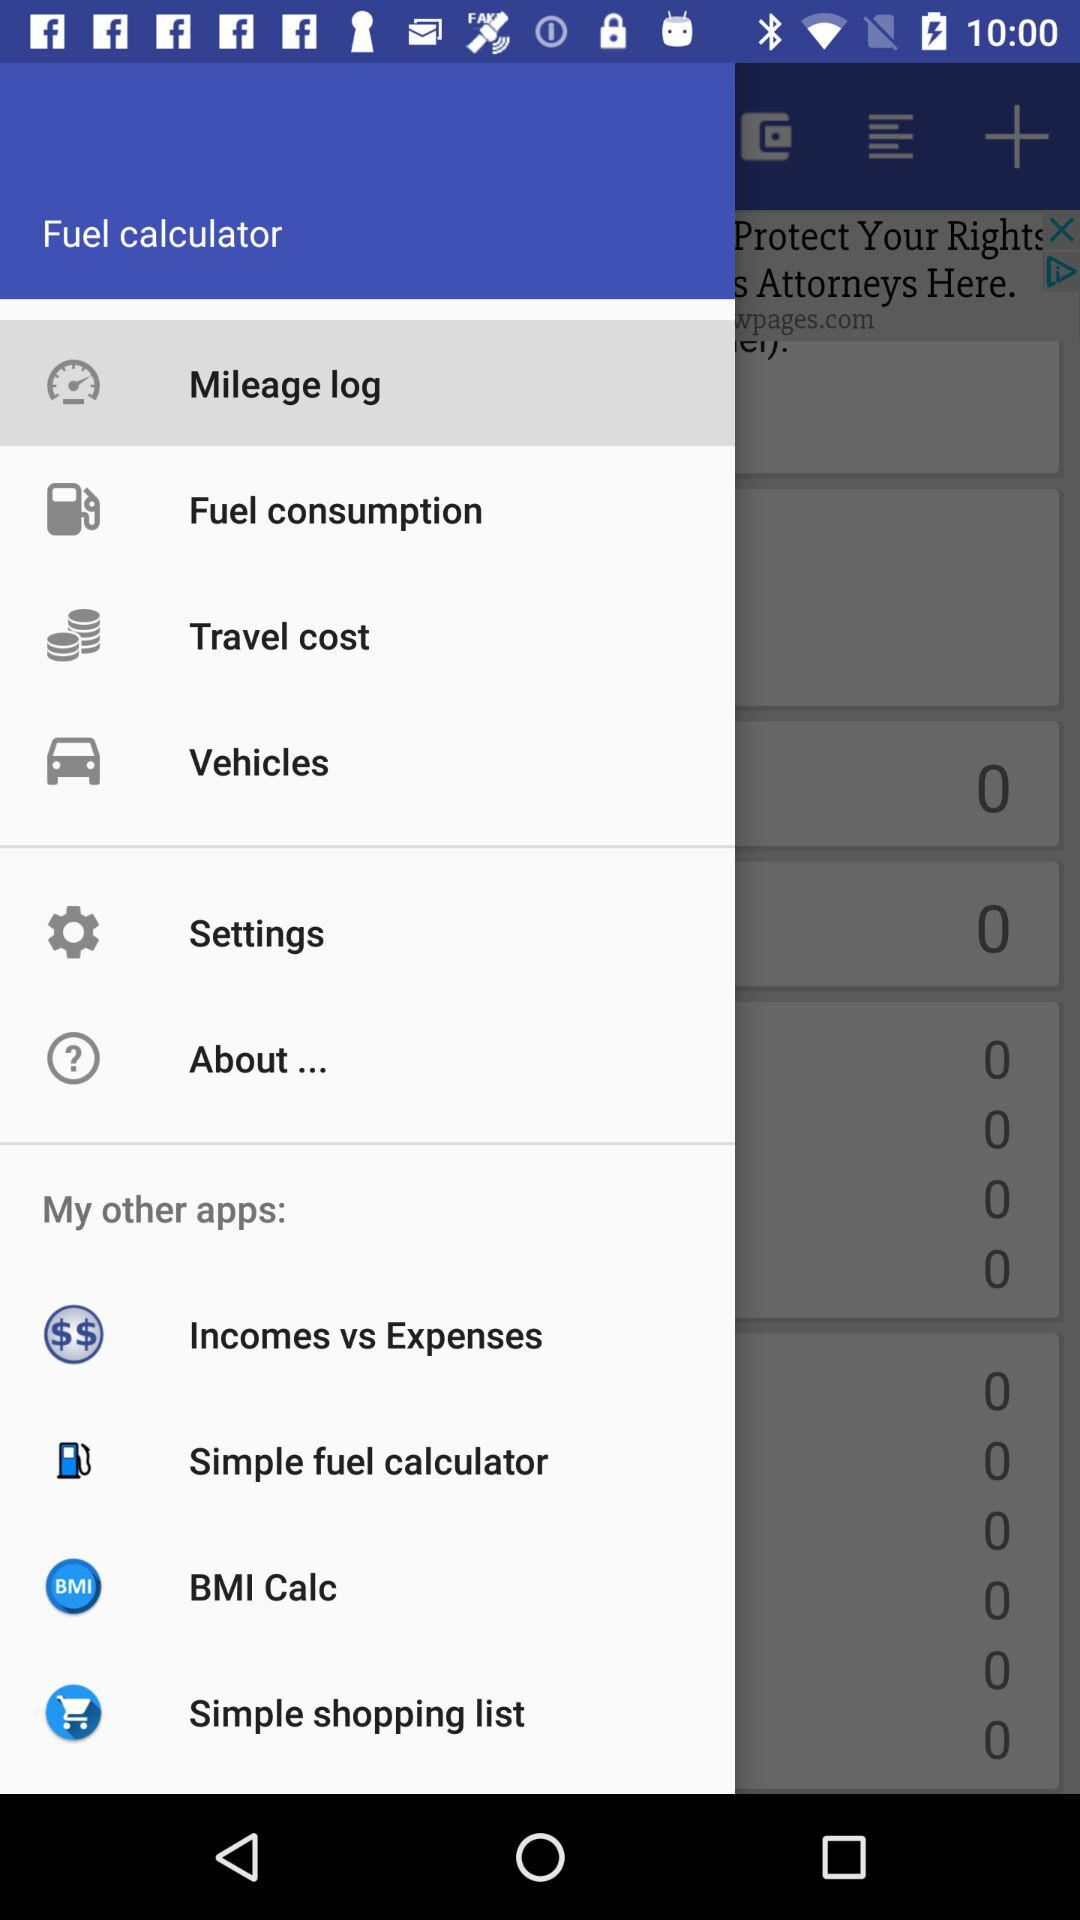Which item is selected in the "Fuel calculator"? The item that is selected in the "Fuel calculator" is "Mileage log". 